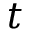<formula> <loc_0><loc_0><loc_500><loc_500>t</formula> 